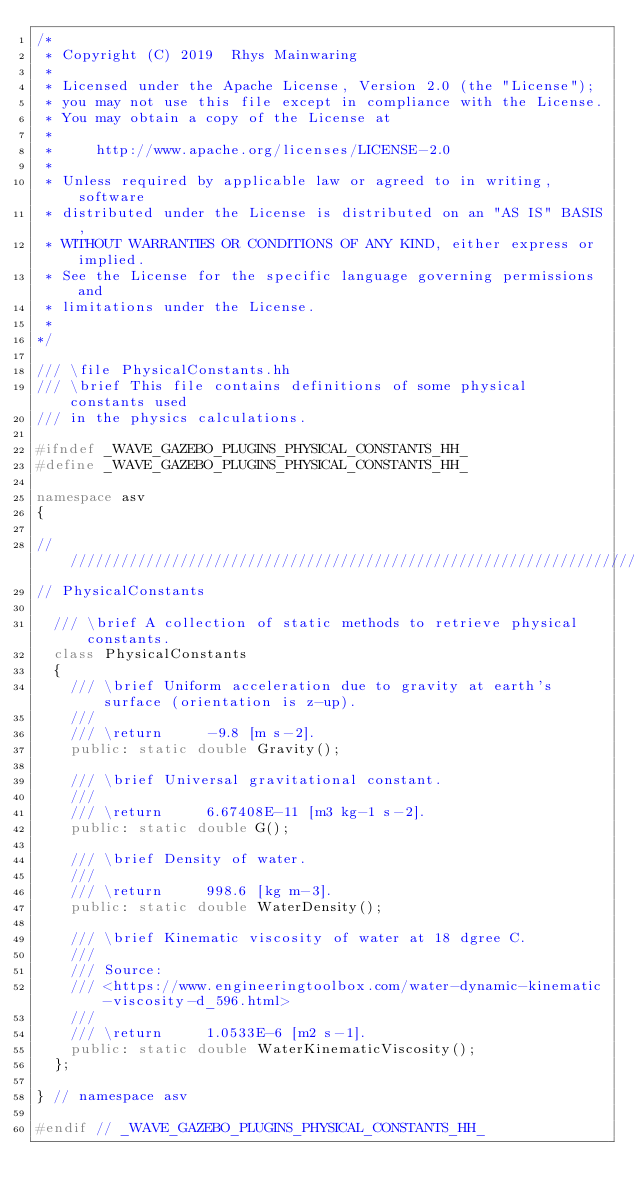<code> <loc_0><loc_0><loc_500><loc_500><_C++_>/*
 * Copyright (C) 2019  Rhys Mainwaring
 *
 * Licensed under the Apache License, Version 2.0 (the "License");
 * you may not use this file except in compliance with the License.
 * You may obtain a copy of the License at
 *
 *     http://www.apache.org/licenses/LICENSE-2.0
 *
 * Unless required by applicable law or agreed to in writing, software
 * distributed under the License is distributed on an "AS IS" BASIS,
 * WITHOUT WARRANTIES OR CONDITIONS OF ANY KIND, either express or implied.
 * See the License for the specific language governing permissions and
 * limitations under the License.
 *
*/

/// \file PhysicalConstants.hh
/// \brief This file contains definitions of some physical constants used 
/// in the physics calculations.

#ifndef _WAVE_GAZEBO_PLUGINS_PHYSICAL_CONSTANTS_HH_
#define _WAVE_GAZEBO_PLUGINS_PHYSICAL_CONSTANTS_HH_

namespace asv
{

///////////////////////////////////////////////////////////////////////////////
// PhysicalConstants

  /// \brief A collection of static methods to retrieve physical constants.
  class PhysicalConstants
  {
    /// \brief Uniform acceleration due to gravity at earth's surface (orientation is z-up).
    ///
    /// \return     -9.8 [m s-2].
    public: static double Gravity(); 
    
    /// \brief Universal gravitational constant.
    ///
    /// \return     6.67408E-11 [m3 kg-1 s-2].
    public: static double G();
    
    /// \brief Density of water.
    ///
    /// \return     998.6 [kg m-3].
    public: static double WaterDensity();

    /// \brief Kinematic viscosity of water at 18 dgree C.
    ///
    /// Source:
    /// <https://www.engineeringtoolbox.com/water-dynamic-kinematic-viscosity-d_596.html>
    ///
    /// \return     1.0533E-6 [m2 s-1].
    public: static double WaterKinematicViscosity();
  };

} // namespace asv

#endif // _WAVE_GAZEBO_PLUGINS_PHYSICAL_CONSTANTS_HH_
</code> 